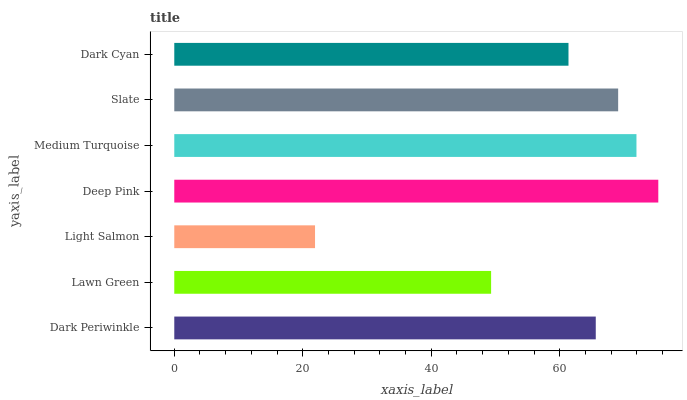Is Light Salmon the minimum?
Answer yes or no. Yes. Is Deep Pink the maximum?
Answer yes or no. Yes. Is Lawn Green the minimum?
Answer yes or no. No. Is Lawn Green the maximum?
Answer yes or no. No. Is Dark Periwinkle greater than Lawn Green?
Answer yes or no. Yes. Is Lawn Green less than Dark Periwinkle?
Answer yes or no. Yes. Is Lawn Green greater than Dark Periwinkle?
Answer yes or no. No. Is Dark Periwinkle less than Lawn Green?
Answer yes or no. No. Is Dark Periwinkle the high median?
Answer yes or no. Yes. Is Dark Periwinkle the low median?
Answer yes or no. Yes. Is Dark Cyan the high median?
Answer yes or no. No. Is Deep Pink the low median?
Answer yes or no. No. 